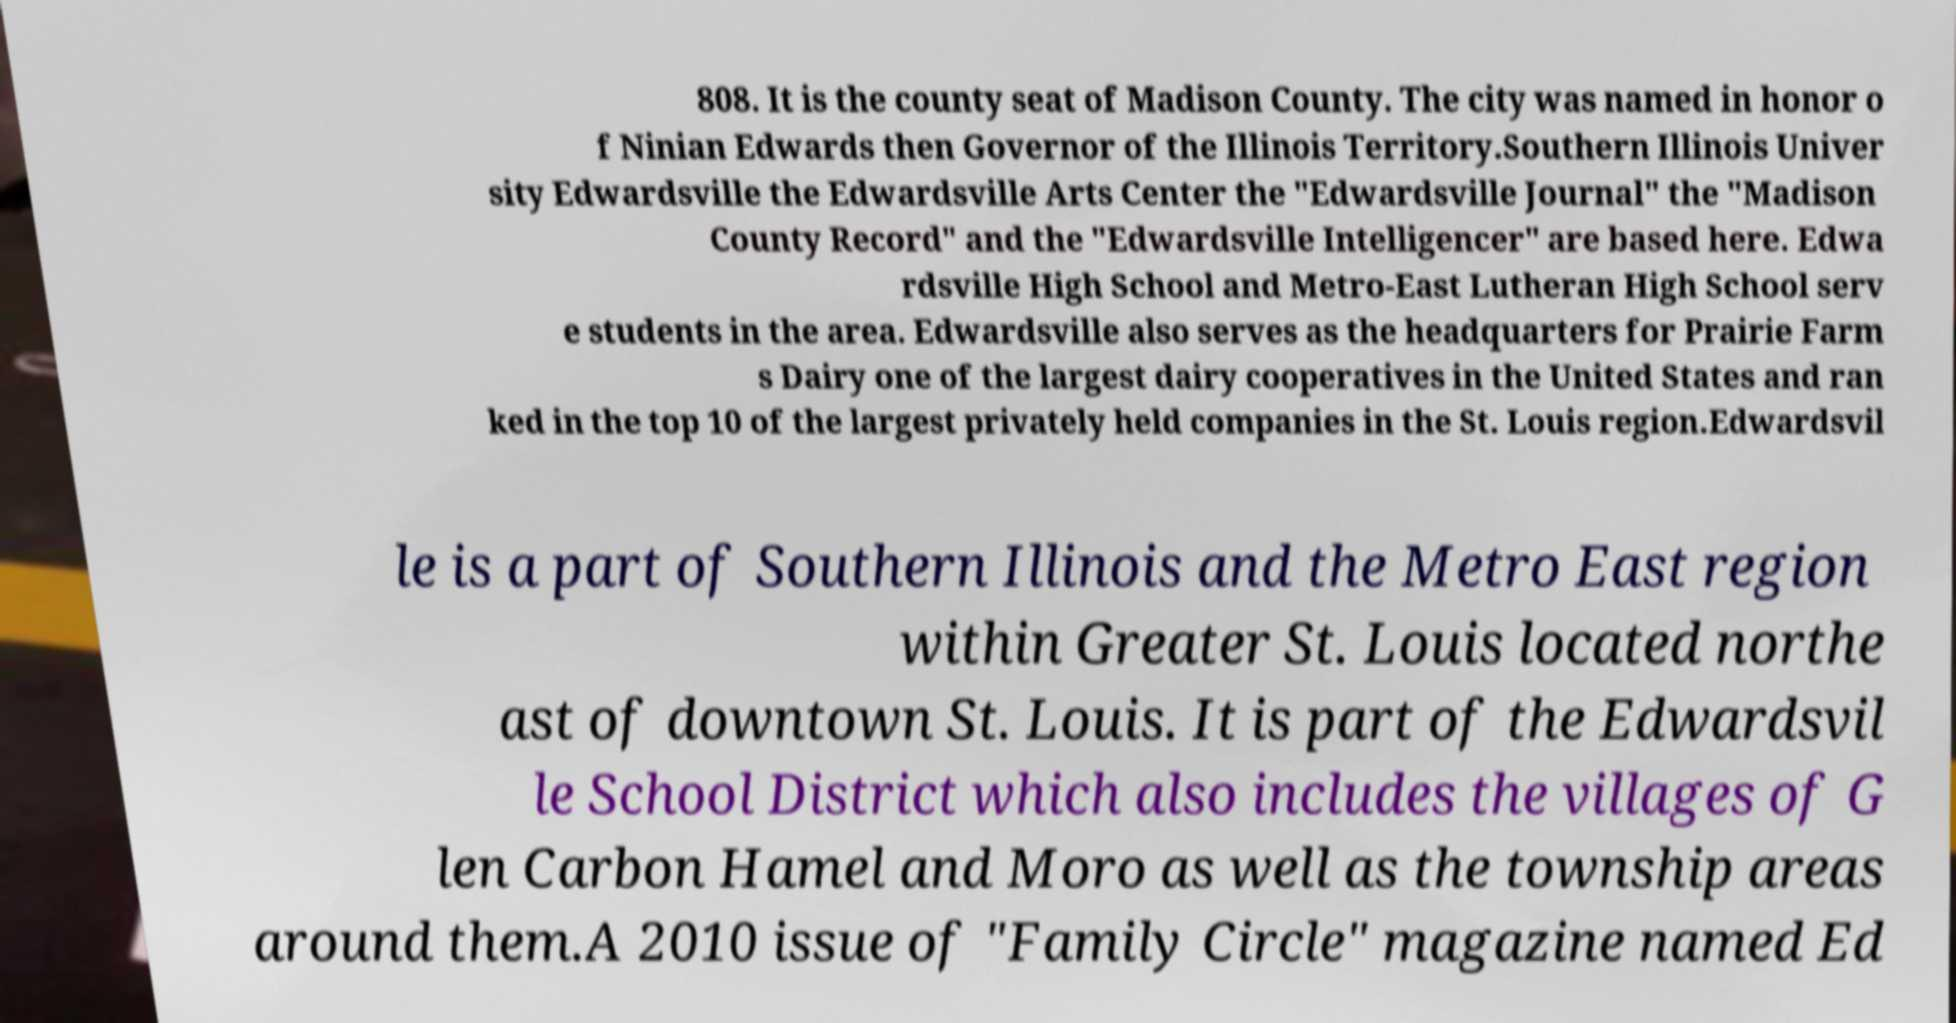Can you read and provide the text displayed in the image?This photo seems to have some interesting text. Can you extract and type it out for me? 808. It is the county seat of Madison County. The city was named in honor o f Ninian Edwards then Governor of the Illinois Territory.Southern Illinois Univer sity Edwardsville the Edwardsville Arts Center the "Edwardsville Journal" the "Madison County Record" and the "Edwardsville Intelligencer" are based here. Edwa rdsville High School and Metro-East Lutheran High School serv e students in the area. Edwardsville also serves as the headquarters for Prairie Farm s Dairy one of the largest dairy cooperatives in the United States and ran ked in the top 10 of the largest privately held companies in the St. Louis region.Edwardsvil le is a part of Southern Illinois and the Metro East region within Greater St. Louis located northe ast of downtown St. Louis. It is part of the Edwardsvil le School District which also includes the villages of G len Carbon Hamel and Moro as well as the township areas around them.A 2010 issue of "Family Circle" magazine named Ed 